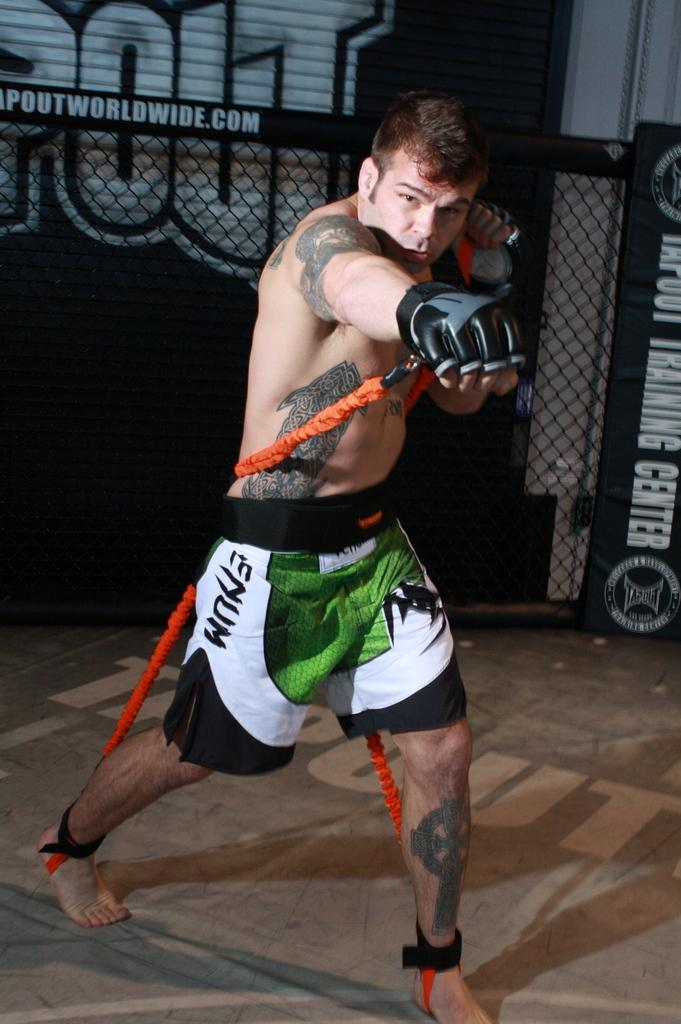Provide a one-sentence caption for the provided image. A man working out with a rope wearing Emum shorts. 